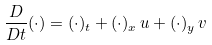Convert formula to latex. <formula><loc_0><loc_0><loc_500><loc_500>\frac { D } { D t } ( \cdot ) = ( \cdot ) _ { t } + ( \cdot ) _ { x } \, u + ( \cdot ) _ { y } \, v</formula> 